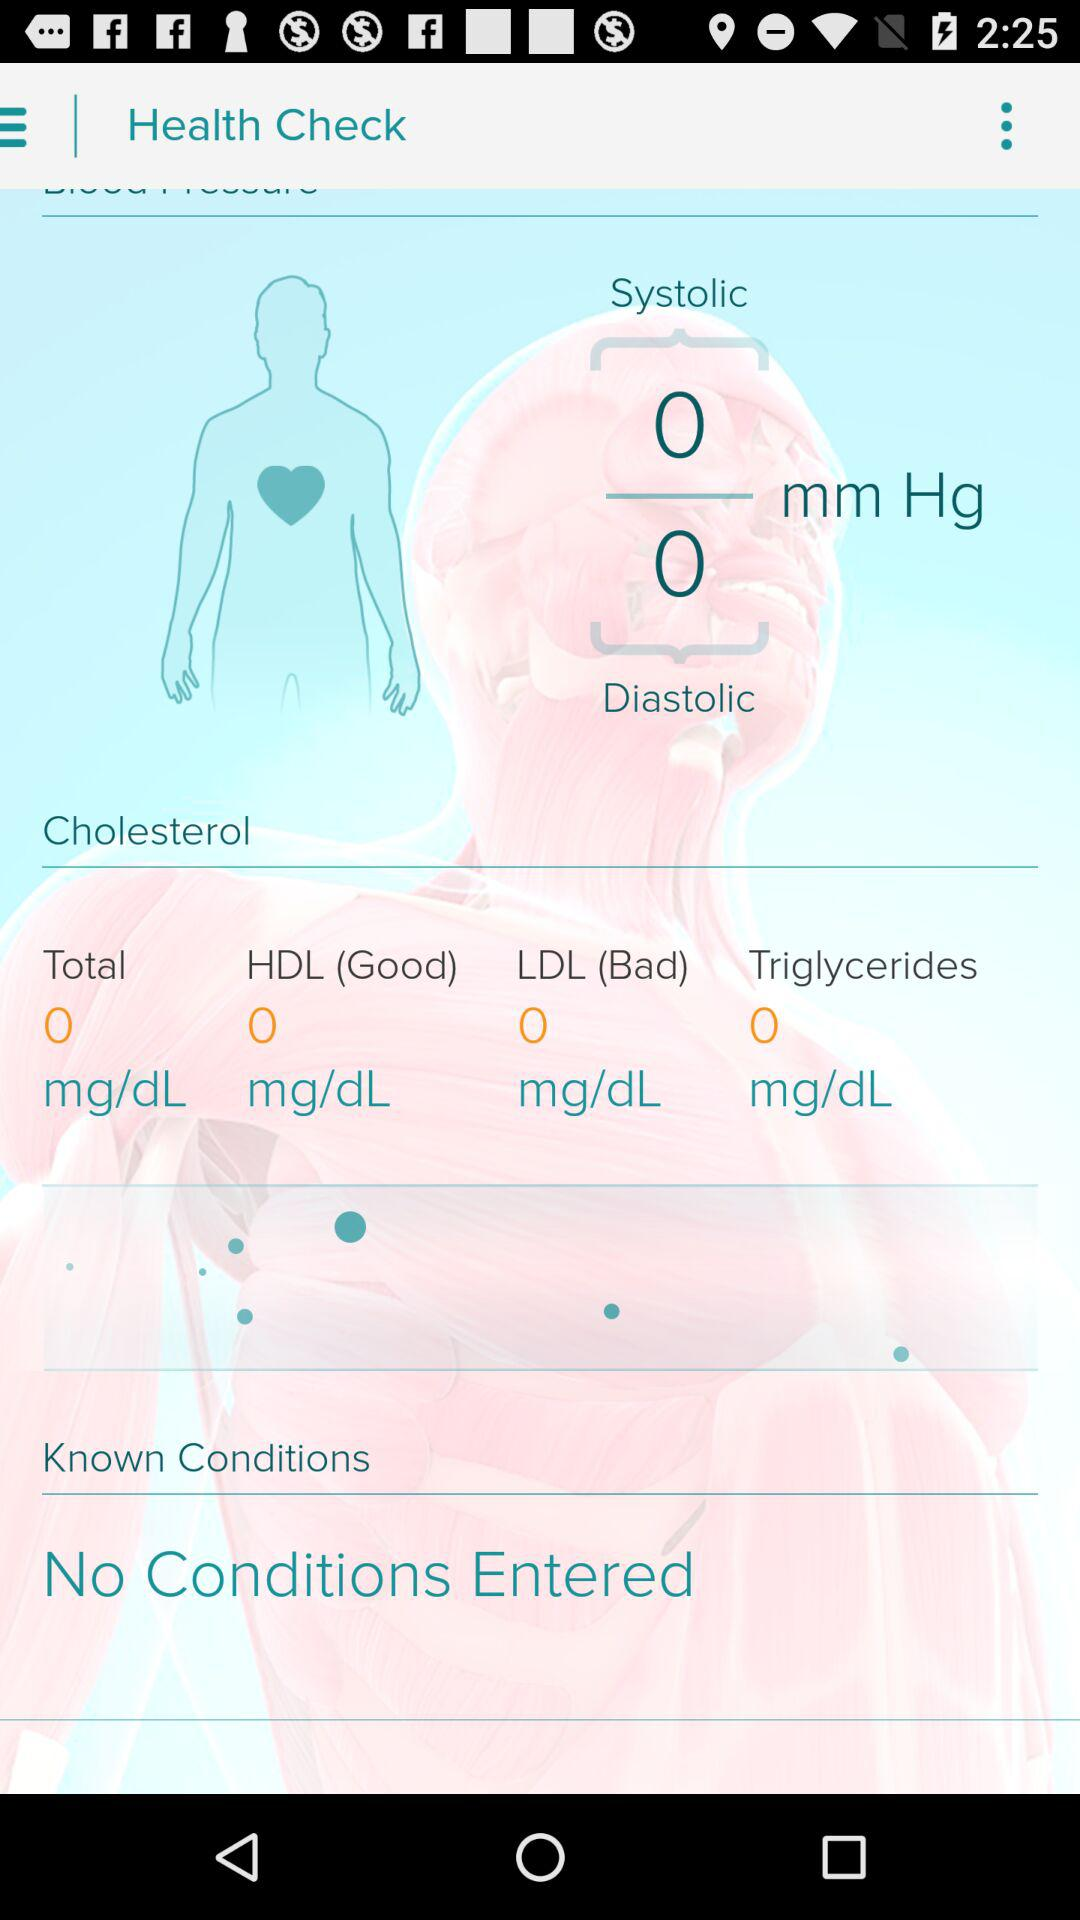Are there any conditions entered? There are no conditions entered. 